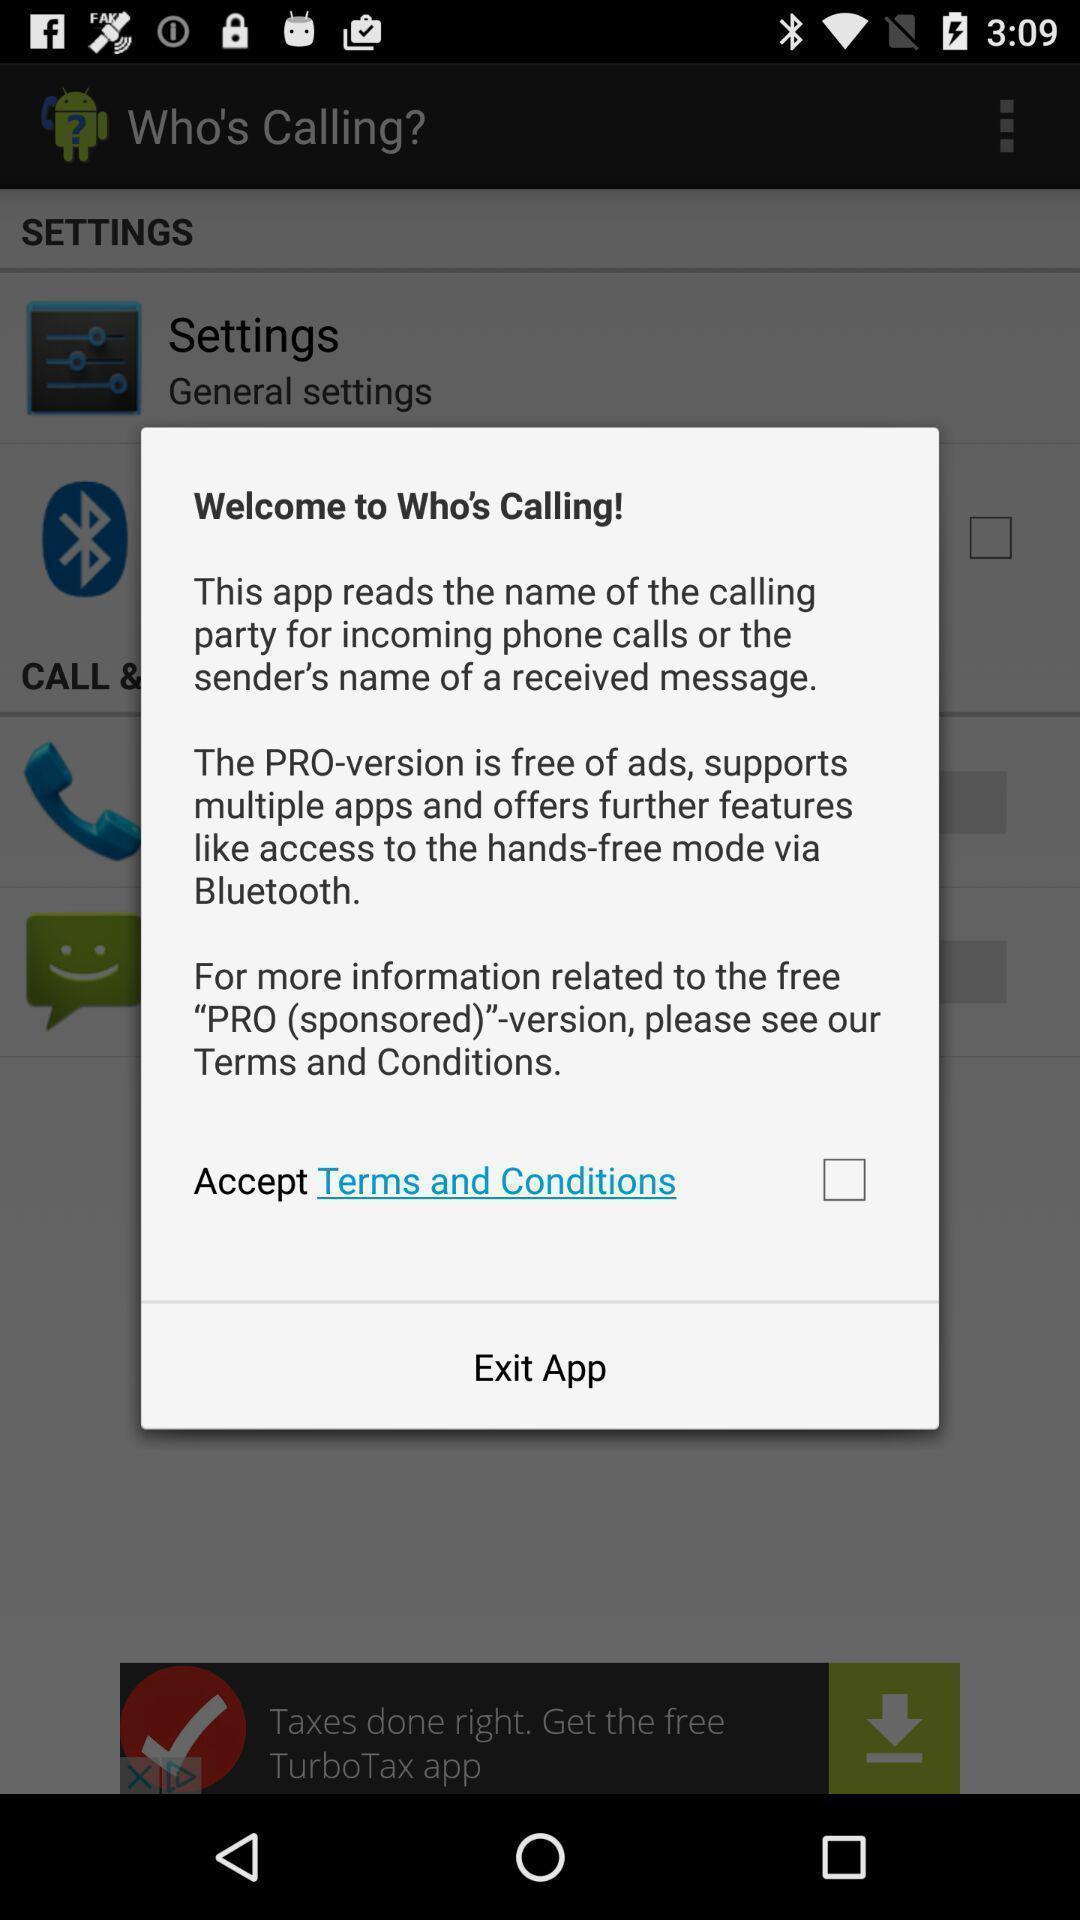Explain the elements present in this screenshot. Pop-up window displaying welcome page. 